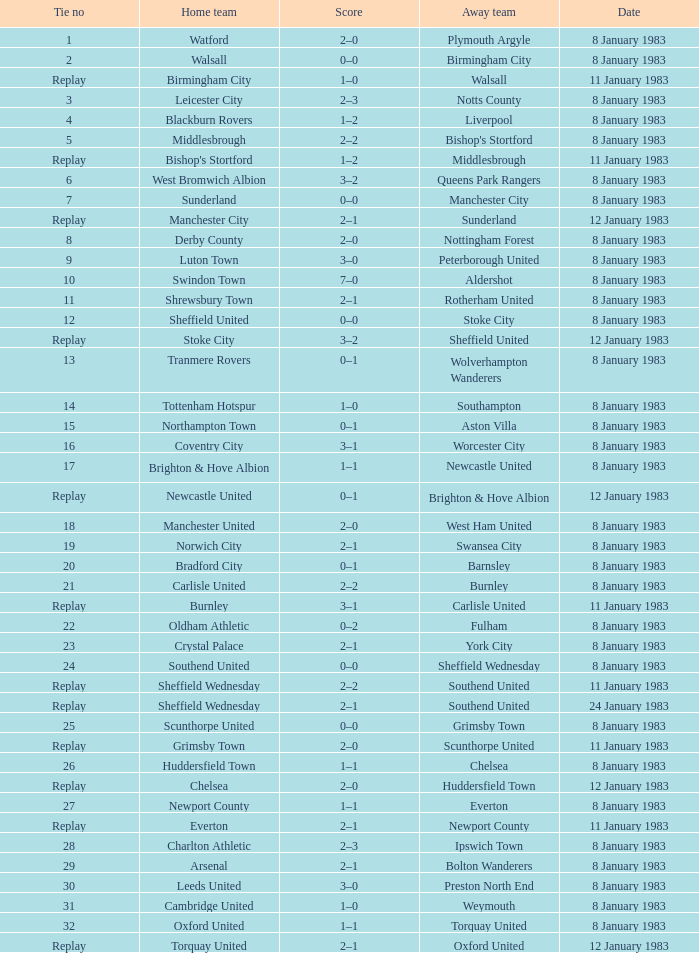For which tie was Scunthorpe United the away team? Replay. 